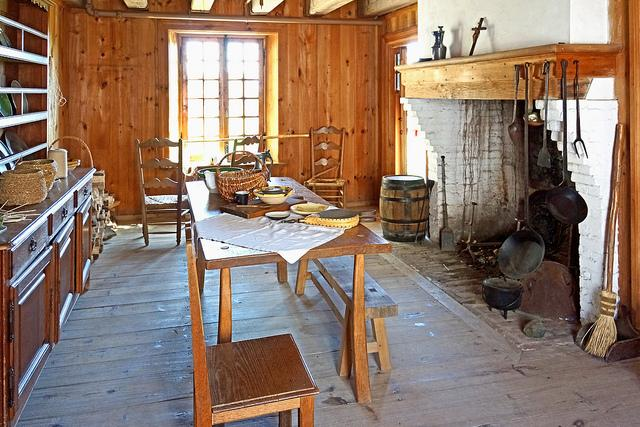What does the item hanging on the wall and closest to the broom look like?

Choices:
A) cross
B) lips
C) straw
D) pitchfork pitchfork 